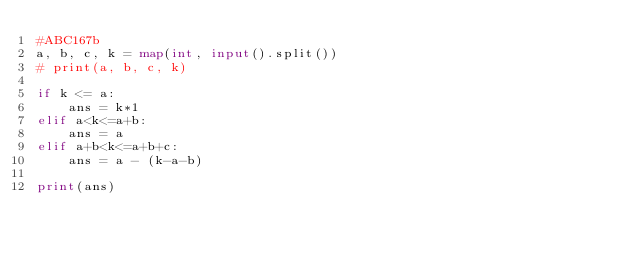Convert code to text. <code><loc_0><loc_0><loc_500><loc_500><_Python_>#ABC167b
a, b, c, k = map(int, input().split())
# print(a, b, c, k)

if k <= a:
    ans = k*1
elif a<k<=a+b:
    ans = a
elif a+b<k<=a+b+c:
    ans = a - (k-a-b)

print(ans)
</code> 